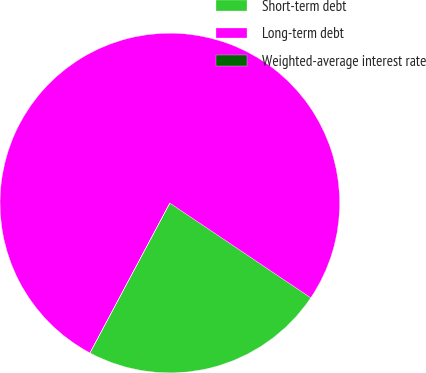Convert chart. <chart><loc_0><loc_0><loc_500><loc_500><pie_chart><fcel>Short-term debt<fcel>Long-term debt<fcel>Weighted-average interest rate<nl><fcel>23.37%<fcel>76.62%<fcel>0.01%<nl></chart> 